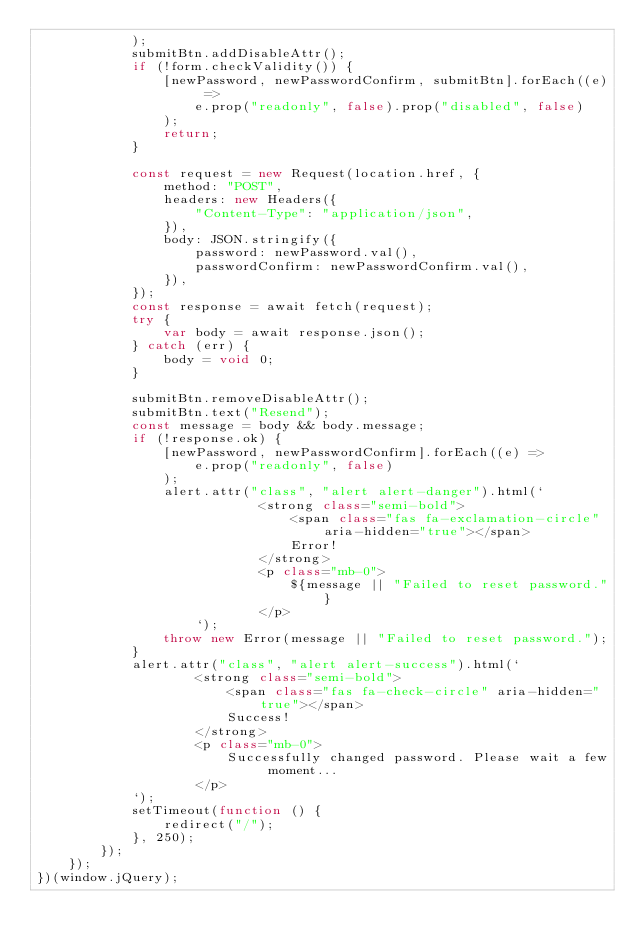Convert code to text. <code><loc_0><loc_0><loc_500><loc_500><_JavaScript_>			);
			submitBtn.addDisableAttr();
			if (!form.checkValidity()) {
				[newPassword, newPasswordConfirm, submitBtn].forEach((e) =>
					e.prop("readonly", false).prop("disabled", false)
				);
				return;
			}

			const request = new Request(location.href, {
				method: "POST",
				headers: new Headers({
					"Content-Type": "application/json",
				}),
				body: JSON.stringify({
					password: newPassword.val(),
					passwordConfirm: newPasswordConfirm.val(),
				}),
			});
			const response = await fetch(request);
			try {
				var body = await response.json();
			} catch (err) {
				body = void 0;
			}

			submitBtn.removeDisableAttr();
			submitBtn.text("Resend");
			const message = body && body.message;
			if (!response.ok) {
				[newPassword, newPasswordConfirm].forEach((e) =>
					e.prop("readonly", false)
				);
				alert.attr("class", "alert alert-danger").html(`
							<strong class="semi-bold">
								<span class="fas fa-exclamation-circle" aria-hidden="true"></span>
								Error!
							</strong>
							<p class="mb-0">
								${message || "Failed to reset password."}
							</p>
					`);
				throw new Error(message || "Failed to reset password.");
			}
			alert.attr("class", "alert alert-success").html(`
					<strong class="semi-bold">
						<span class="fas fa-check-circle" aria-hidden="true"></span>
						Success!
					</strong>
					<p class="mb-0">
						Successfully changed password. Please wait a few moment...
					</p>
			`);
			setTimeout(function () {
				redirect("/");
			}, 250);
		});
	});
})(window.jQuery);
</code> 